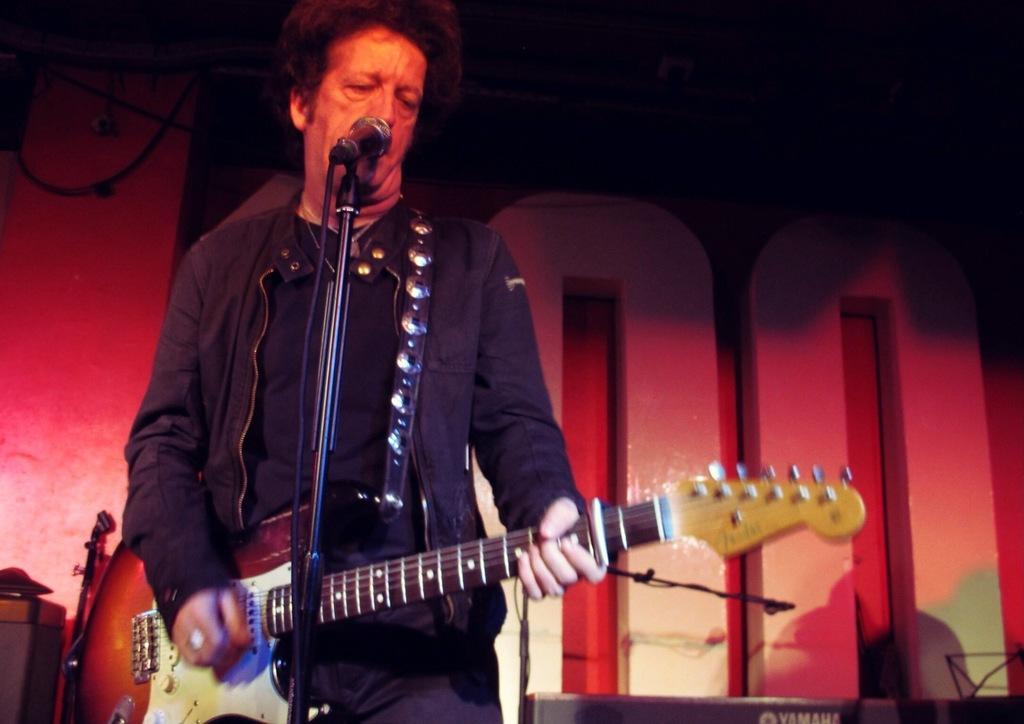How would you summarize this image in a sentence or two? This is a picture of a man in black jacket holding a guitar. The man is singing a song in front of the man there is a microphone with stand. Background of the man is a wall. 